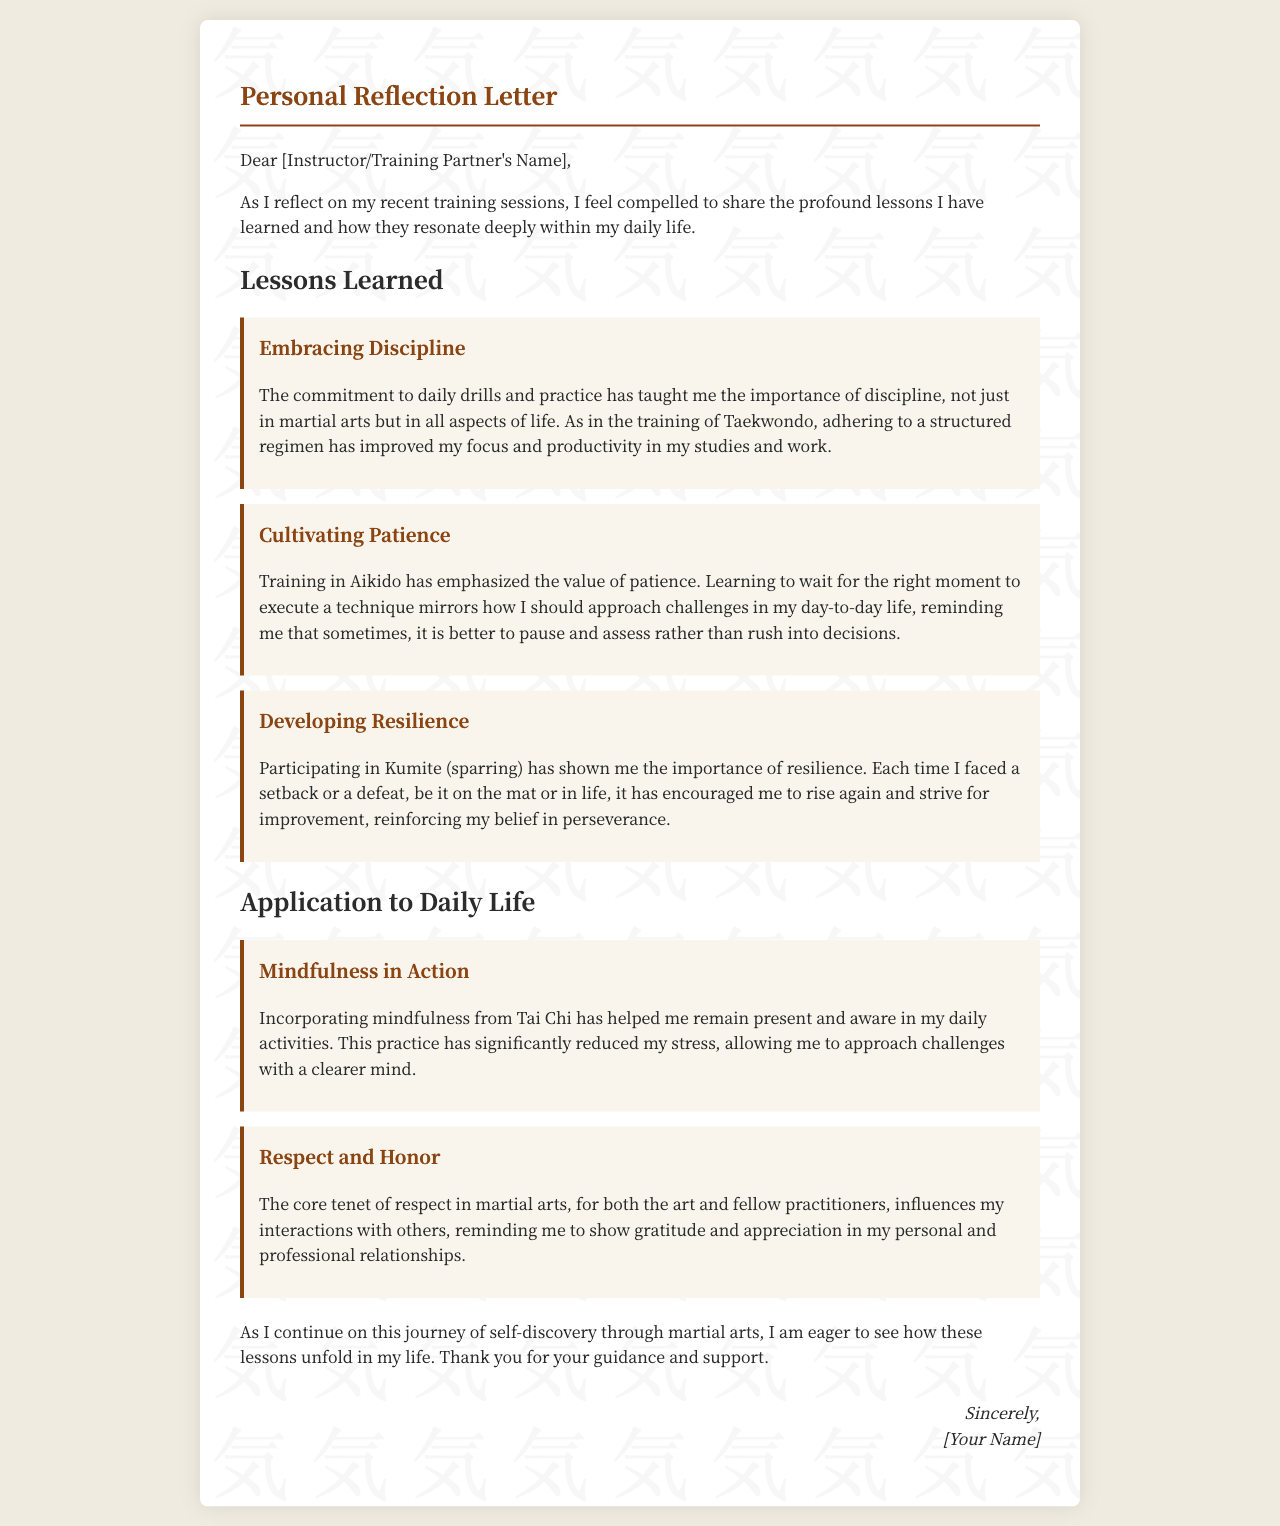What is the main theme of the letter? The letter focuses on personal lessons learned from martial arts training and their impact on daily life.
Answer: Personal growth Who is the letter addressed to? The salutation indicates that the letter is directed towards someone who has guided or partnered in the training journey.
Answer: [Instructor/Training Partner's Name] What are the titles of the lessons learned? The letter enumerates specific lessons focused on personal development through martial arts.
Answer: Embracing Discipline, Cultivating Patience, Developing Resilience What martial art is associated with mindfulness? The letter describes the incorporation of mindfulness practice from a specific martial art style.
Answer: Tai Chi How does the author apply the lesson of resilience in daily life? The text connects the practice of resilience learned through sparring to overcoming personal setbacks.
Answer: Encouragement to rise again What value does training in Aikido emphasize according to the letter? The letter specifies a core value learned through Aikido that influences decision-making.
Answer: Patience What is the focus of the application to daily life section? This section details how martial arts principles are translated into everyday behavior and mindset.
Answer: Mindfulness and respect Who is the recipient of gratitude at the end of the letter? The closing remarks express thanks to someone who has played a supportive role in the author's journey.
Answer: [Your Name] What impact does the author claim their training has on stress? The letter asserts that a particular practice helps in managing daily stress effectively.
Answer: Significantly reduced stress 